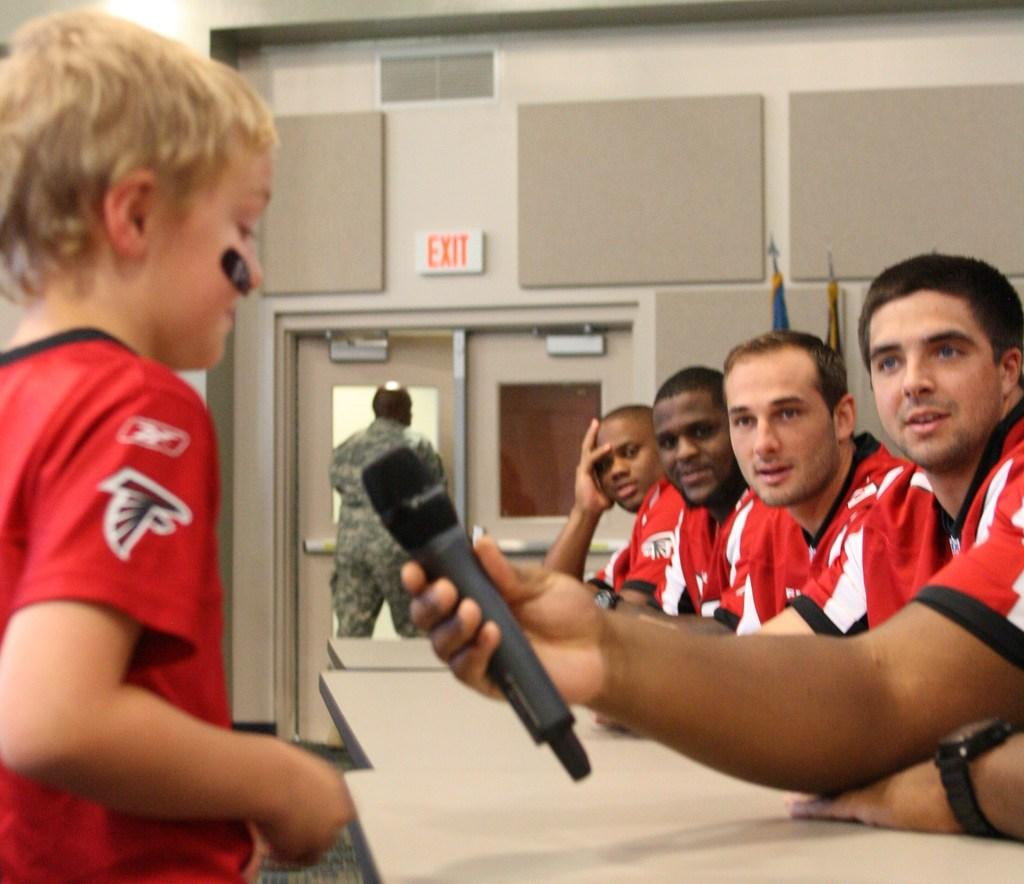<image>
Provide a brief description of the given image. Men with Falcons uniforms look at boy wearing same jersey talk into microphone while a soldier leaves in door marked Exit 